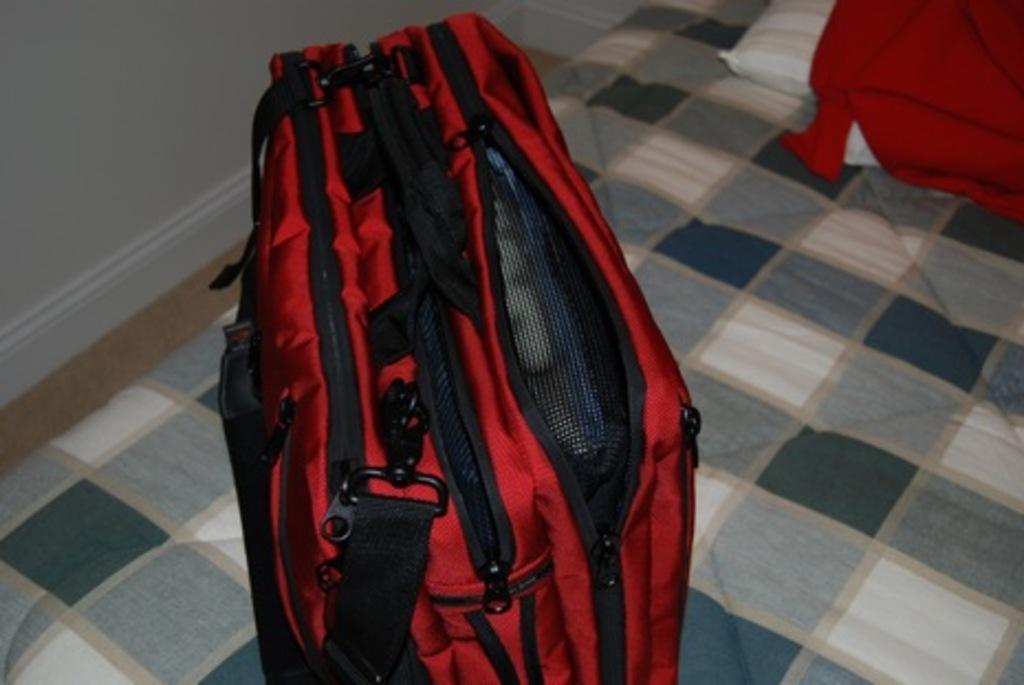What object can be seen in the image that is typically used for carrying items? There is a bag in the image. What piece of furniture is present in the image that is used for sleeping? There is a bed in the image. What item is visible in the image that is used for supporting the head while sleeping? There is a pillow in the image. What type of structure can be seen in the image that serves as a barrier or boundary? There is a wall in the image. What type of animal can be seen using its tongue to lick the wall in the image? There are no animals present in the image, and therefore no such activity can be observed. What type of creature can be seen with fangs in the image? There are no creatures with fangs present in the image. 